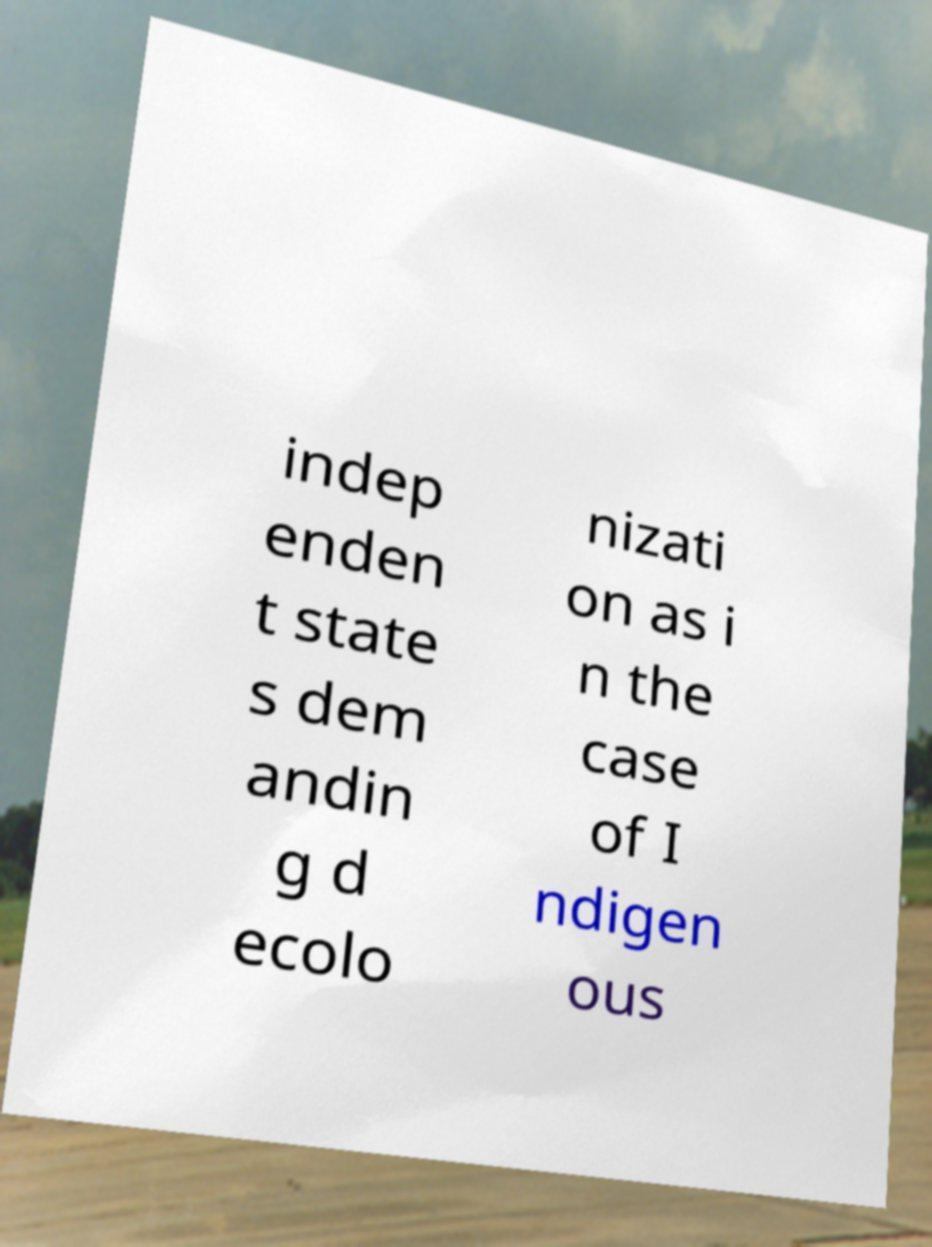Could you extract and type out the text from this image? indep enden t state s dem andin g d ecolo nizati on as i n the case of I ndigen ous 